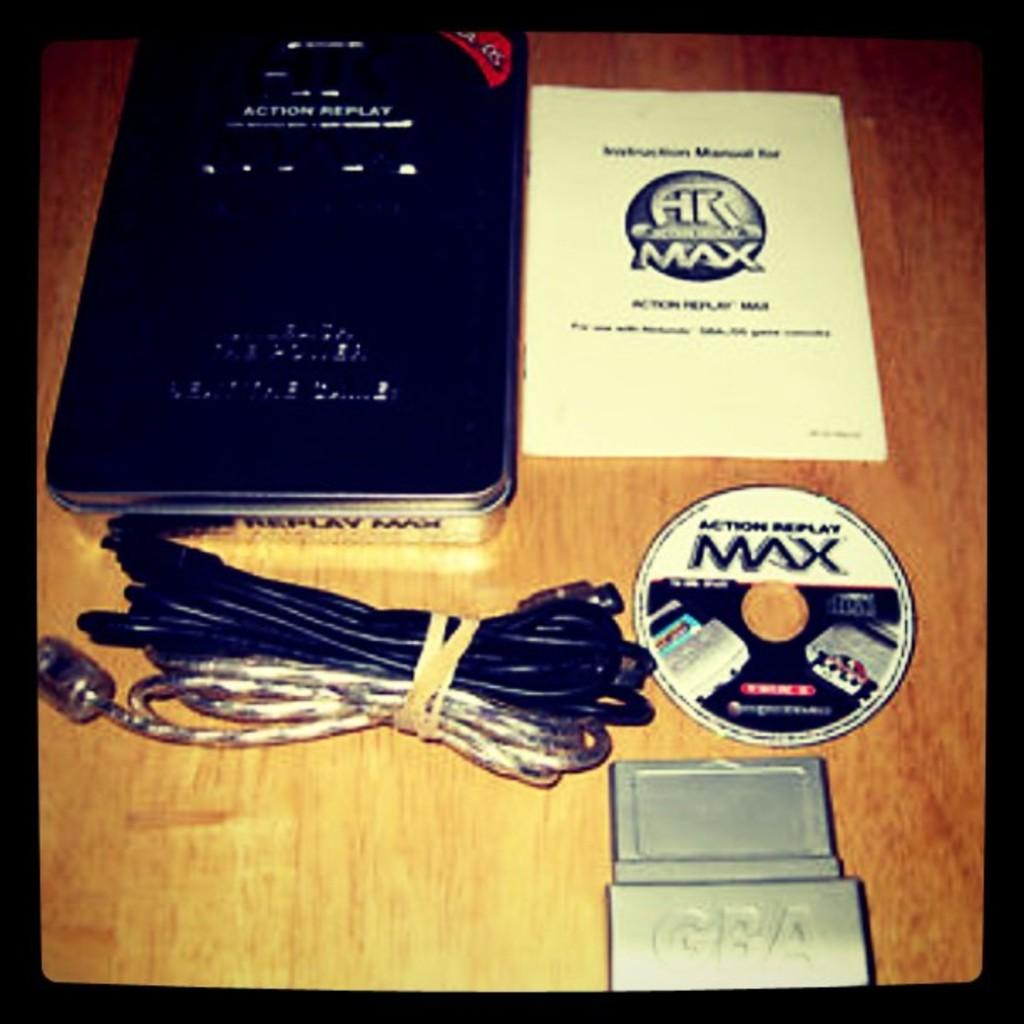<image>
Describe the image concisely. Seems to be a video game and instructions and components titled Action Replay Max. 